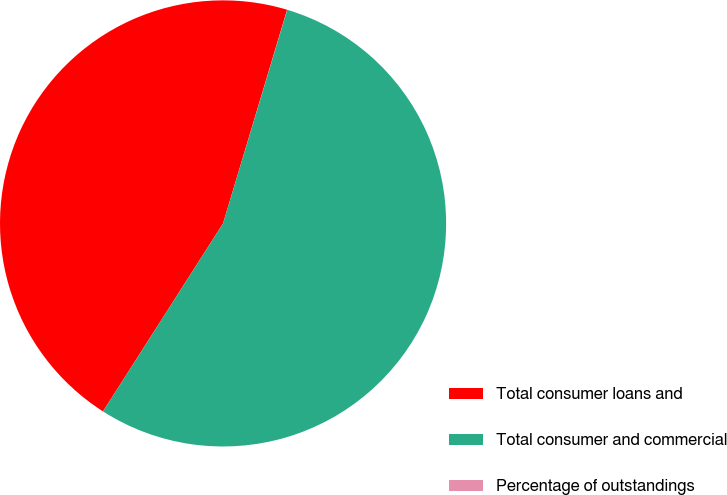<chart> <loc_0><loc_0><loc_500><loc_500><pie_chart><fcel>Total consumer loans and<fcel>Total consumer and commercial<fcel>Percentage of outstandings<nl><fcel>45.59%<fcel>54.4%<fcel>0.01%<nl></chart> 